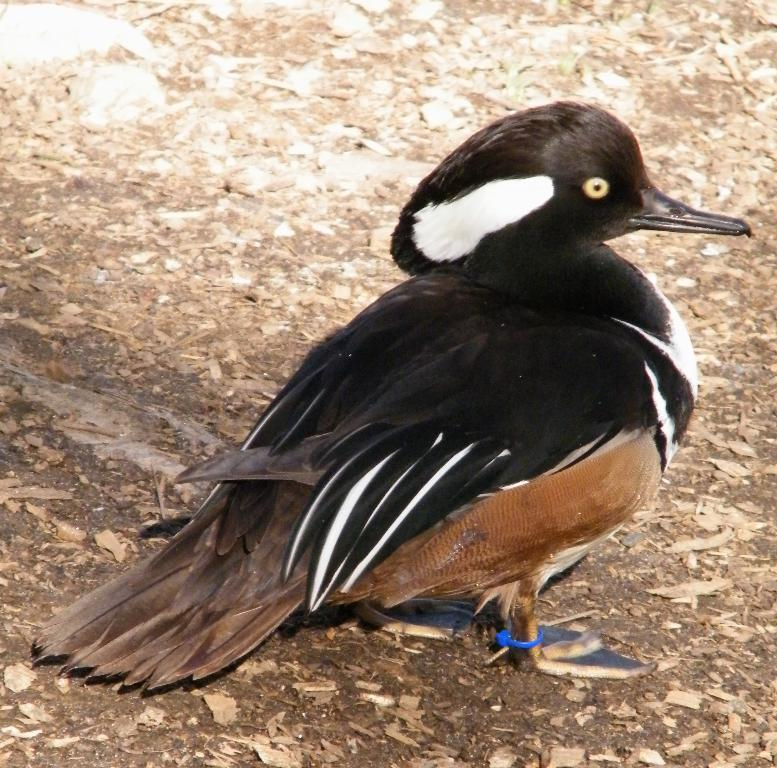What type of animal is in the image? There is a bird in the image. Where is the bird located? The bird is standing on the ground. Is there any identification or marking on the bird? Yes, there is a tag around the bird's leg. What else can be seen on the ground in the image? Dried leaves are present on the ground. What type of honey is the bird collecting in the image? There is no honey present in the image, nor is the bird collecting any honey. 